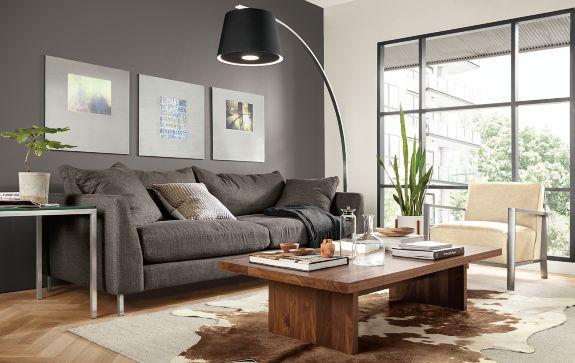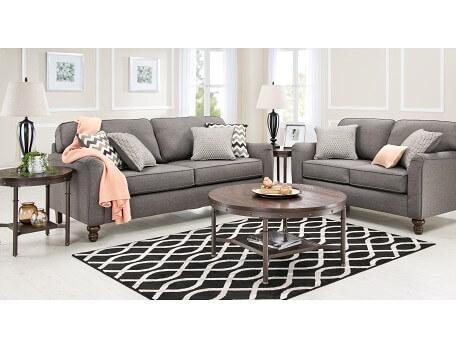The first image is the image on the left, the second image is the image on the right. For the images shown, is this caption "A gooseneck lamp is in front of a large paned window in a room with a sofa and coffee table." true? Answer yes or no. Yes. The first image is the image on the left, the second image is the image on the right. Evaluate the accuracy of this statement regarding the images: "there is a white built in bookshelf with a sofa , two chairs and a coffee table in front of it". Is it true? Answer yes or no. No. 